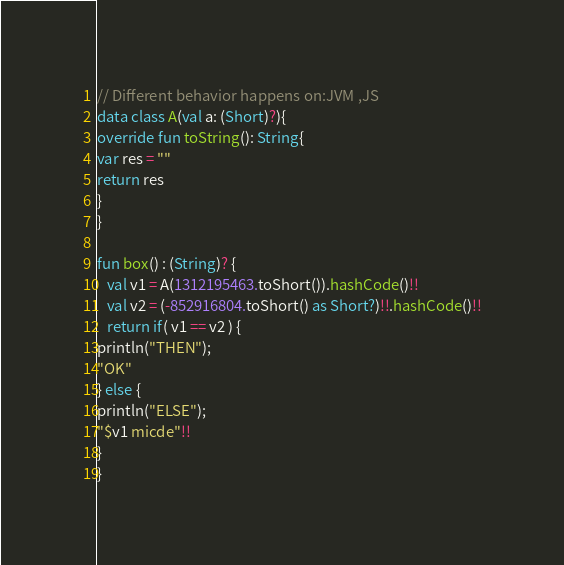Convert code to text. <code><loc_0><loc_0><loc_500><loc_500><_Kotlin_>// Different behavior happens on:JVM ,JS 
data class A(val a: (Short)?){
override fun toString(): String{
var res = ""
return res
}
}

fun box() : (String)? {
   val v1 = A(1312195463.toShort()).hashCode()!!
   val v2 = (-852916804.toShort() as Short?)!!.hashCode()!!
   return if( v1 == v2 ) {
println("THEN");
"OK"
} else {
println("ELSE");
"$v1 micde"!!
}
}
</code> 